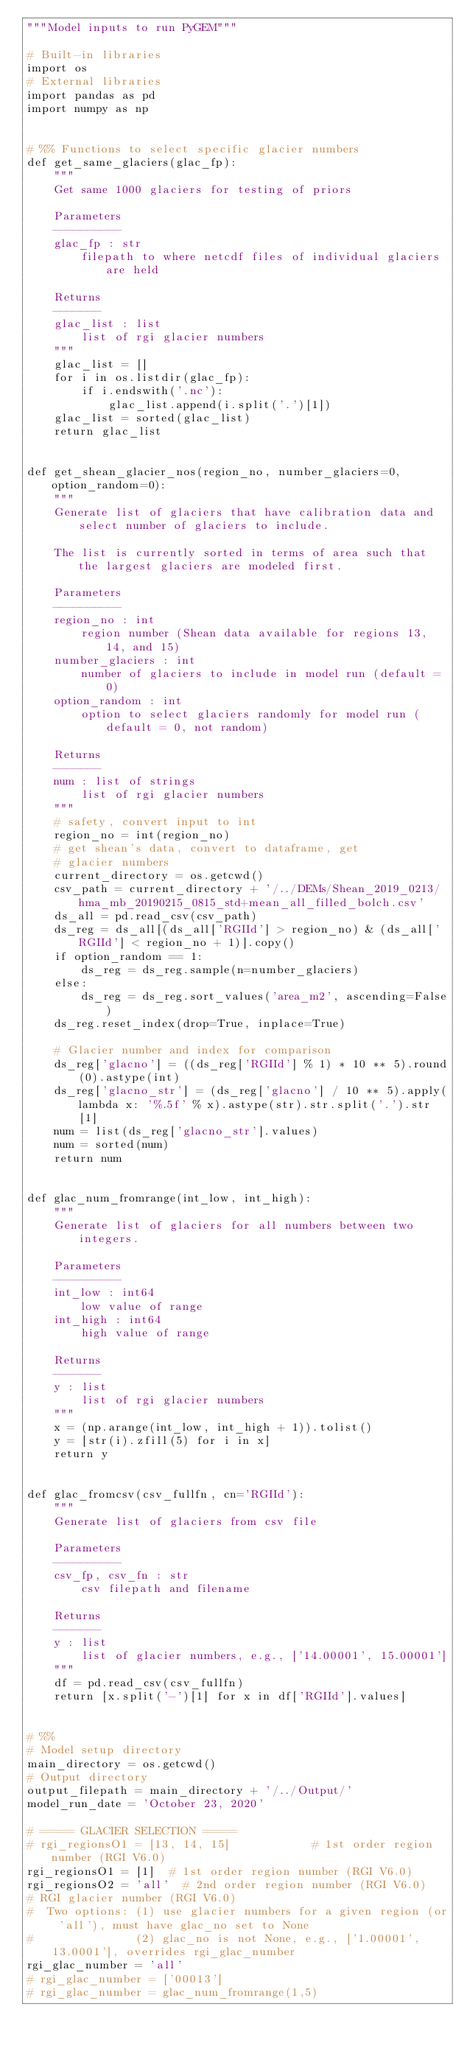Convert code to text. <code><loc_0><loc_0><loc_500><loc_500><_Python_>"""Model inputs to run PyGEM"""

# Built-in libraries
import os
# External libraries
import pandas as pd
import numpy as np


# %% Functions to select specific glacier numbers
def get_same_glaciers(glac_fp):
    """
    Get same 1000 glaciers for testing of priors

    Parameters
    ----------
    glac_fp : str
        filepath to where netcdf files of individual glaciers are held

    Returns
    -------
    glac_list : list
        list of rgi glacier numbers
    """
    glac_list = []
    for i in os.listdir(glac_fp):
        if i.endswith('.nc'):
            glac_list.append(i.split('.')[1])
    glac_list = sorted(glac_list)
    return glac_list


def get_shean_glacier_nos(region_no, number_glaciers=0, option_random=0):
    """
    Generate list of glaciers that have calibration data and select number of glaciers to include.

    The list is currently sorted in terms of area such that the largest glaciers are modeled first.

    Parameters
    ----------
    region_no : int
        region number (Shean data available for regions 13, 14, and 15)
    number_glaciers : int
        number of glaciers to include in model run (default = 0)
    option_random : int
        option to select glaciers randomly for model run (default = 0, not random)

    Returns
    -------
    num : list of strings
        list of rgi glacier numbers
    """
    # safety, convert input to int
    region_no = int(region_no)
    # get shean's data, convert to dataframe, get
    # glacier numbers
    current_directory = os.getcwd()
    csv_path = current_directory + '/../DEMs/Shean_2019_0213/hma_mb_20190215_0815_std+mean_all_filled_bolch.csv'
    ds_all = pd.read_csv(csv_path)
    ds_reg = ds_all[(ds_all['RGIId'] > region_no) & (ds_all['RGIId'] < region_no + 1)].copy()
    if option_random == 1:
        ds_reg = ds_reg.sample(n=number_glaciers)
    else:
        ds_reg = ds_reg.sort_values('area_m2', ascending=False)
    ds_reg.reset_index(drop=True, inplace=True)

    # Glacier number and index for comparison
    ds_reg['glacno'] = ((ds_reg['RGIId'] % 1) * 10 ** 5).round(0).astype(int)
    ds_reg['glacno_str'] = (ds_reg['glacno'] / 10 ** 5).apply(lambda x: '%.5f' % x).astype(str).str.split('.').str[1]
    num = list(ds_reg['glacno_str'].values)
    num = sorted(num)
    return num


def glac_num_fromrange(int_low, int_high):
    """
    Generate list of glaciers for all numbers between two integers.

    Parameters
    ----------
    int_low : int64
        low value of range
    int_high : int64
        high value of range

    Returns
    -------
    y : list
        list of rgi glacier numbers
    """
    x = (np.arange(int_low, int_high + 1)).tolist()
    y = [str(i).zfill(5) for i in x]
    return y


def glac_fromcsv(csv_fullfn, cn='RGIId'):
    """
    Generate list of glaciers from csv file

    Parameters
    ----------
    csv_fp, csv_fn : str
        csv filepath and filename

    Returns
    -------
    y : list
        list of glacier numbers, e.g., ['14.00001', 15.00001']
    """
    df = pd.read_csv(csv_fullfn)
    return [x.split('-')[1] for x in df['RGIId'].values]


# %%
# Model setup directory
main_directory = os.getcwd()
# Output directory
output_filepath = main_directory + '/../Output/'
model_run_date = 'October 23, 2020'

# ===== GLACIER SELECTION =====
# rgi_regionsO1 = [13, 14, 15]            # 1st order region number (RGI V6.0)
rgi_regionsO1 = [1]  # 1st order region number (RGI V6.0)
rgi_regionsO2 = 'all'  # 2nd order region number (RGI V6.0)
# RGI glacier number (RGI V6.0)
#  Two options: (1) use glacier numbers for a given region (or 'all'), must have glac_no set to None
#               (2) glac_no is not None, e.g., ['1.00001', 13.0001'], overrides rgi_glac_number
rgi_glac_number = 'all'
# rgi_glac_number = ['00013']
# rgi_glac_number = glac_num_fromrange(1,5)</code> 